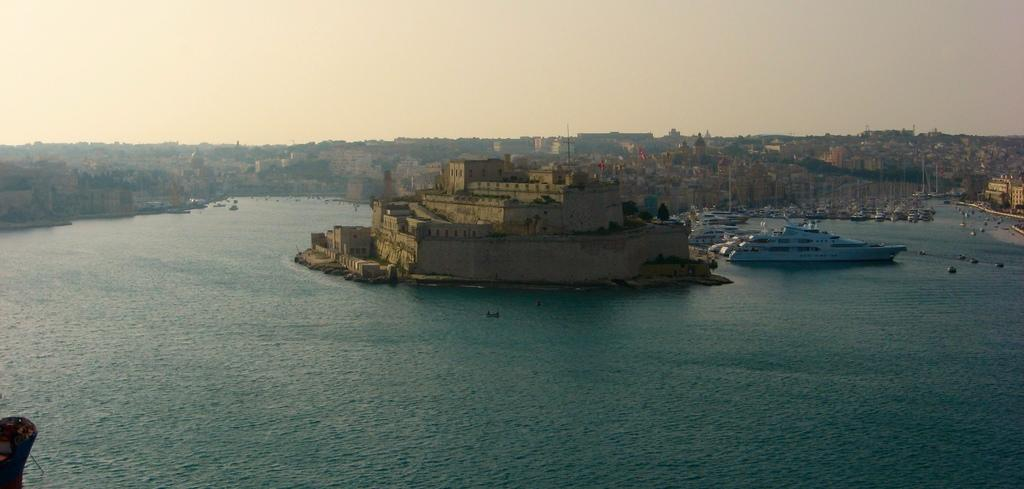What is the primary element in the image? There is water in the image. What is floating on the water? Ships are floating on the water. What type of structure can be seen in the image? There is a stone building in the image. Are there any other buildings in the image? Yes, there are additional buildings in the image. What can be seen in the background of the image? The sky is visible in the background of the image. How many heads of lettuce can be seen floating in the water? There are no heads of lettuce present in the image; it features water, ships, and buildings. 